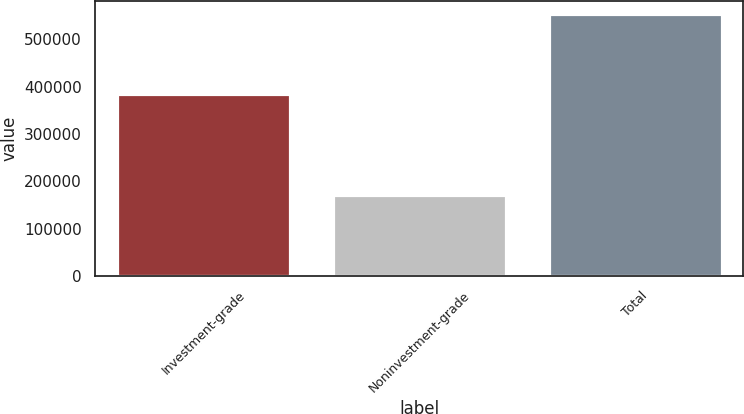<chart> <loc_0><loc_0><loc_500><loc_500><bar_chart><fcel>Investment-grade<fcel>Noninvestment-grade<fcel>Total<nl><fcel>383586<fcel>170046<fcel>553632<nl></chart> 